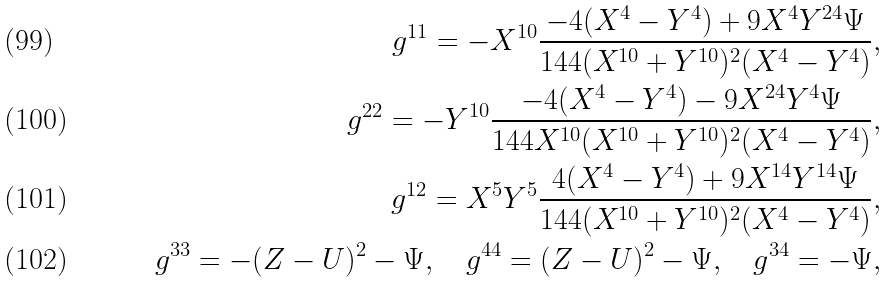<formula> <loc_0><loc_0><loc_500><loc_500>g ^ { 1 1 } = - X ^ { 1 0 } \frac { - 4 ( X ^ { 4 } - Y ^ { 4 } ) + 9 X ^ { 4 } Y ^ { 2 4 } \Psi } { 1 4 4 ( X ^ { 1 0 } + Y ^ { 1 0 } ) ^ { 2 } ( X ^ { 4 } - Y ^ { 4 } ) } , \\ g ^ { 2 2 } = - Y ^ { 1 0 } \frac { - 4 ( X ^ { 4 } - Y ^ { 4 } ) - 9 X ^ { 2 4 } Y ^ { 4 } \Psi } { 1 4 4 X ^ { 1 0 } ( X ^ { 1 0 } + Y ^ { 1 0 } ) ^ { 2 } ( X ^ { 4 } - Y ^ { 4 } ) } , \\ g ^ { 1 2 } = X ^ { 5 } Y ^ { 5 } \frac { 4 ( X ^ { 4 } - Y ^ { 4 } ) + 9 X ^ { 1 4 } Y ^ { 1 4 } \Psi } { 1 4 4 ( X ^ { 1 0 } + Y ^ { 1 0 } ) ^ { 2 } ( X ^ { 4 } - Y ^ { 4 } ) } , \\ g ^ { 3 3 } = - ( Z - U ) ^ { 2 } - \Psi , \quad g ^ { 4 4 } = ( Z - U ) ^ { 2 } - \Psi , \quad g ^ { 3 4 } = - \Psi ,</formula> 